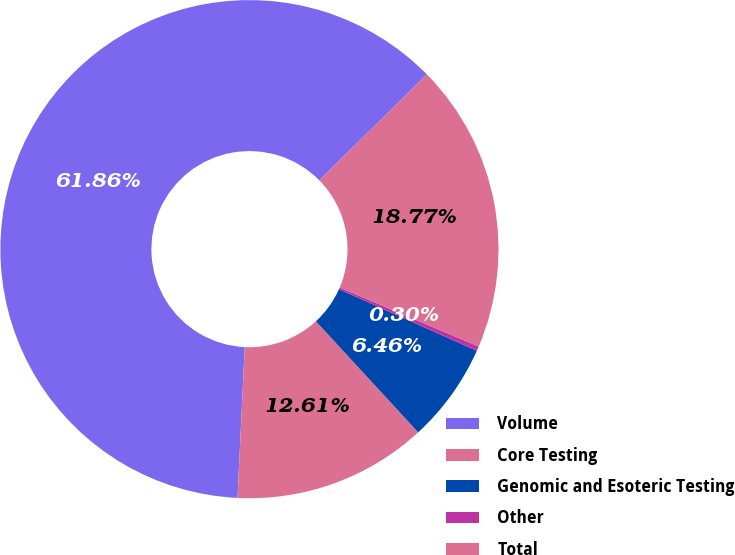<chart> <loc_0><loc_0><loc_500><loc_500><pie_chart><fcel>Volume<fcel>Core Testing<fcel>Genomic and Esoteric Testing<fcel>Other<fcel>Total<nl><fcel>61.85%<fcel>12.61%<fcel>6.46%<fcel>0.3%<fcel>18.77%<nl></chart> 